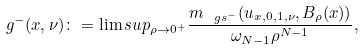<formula> <loc_0><loc_0><loc_500><loc_500>g ^ { - } ( x , \nu ) \colon = \lim s u p _ { \rho \to 0 ^ { + } } \frac { { m } _ { \ g s ^ { - } } ( u _ { x , 0 , 1 , \nu } , B _ { \rho } ( x ) ) } { \omega _ { N - 1 } \rho ^ { N - 1 } } ,</formula> 